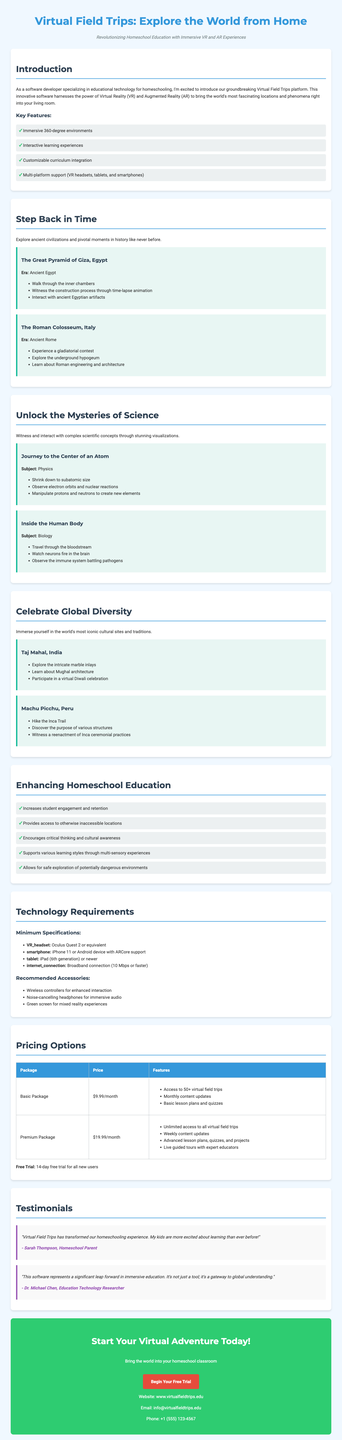what is the tagline of the brochure? The tagline is a phrase that captures the essence of the brochure, positioned prominently to attract attention.
Answer: Revolutionizing Homeschool Education with Immersive VR and AR Experiences how many historical sites are featured? The number of historical sites includes those listed under the historical sites section, specifically mentioned in the document.
Answer: 2 what is included in the Premium Package? The Premium Package consists of several features that enhance the educational experience, as detailed under pricing options.
Answer: Unlimited access to all virtual field trips, weekly content updates, advanced lesson plans, quizzes, and projects, live guided tours with expert educators which technology is required for accessing the platform? This refers to the specific requirements outlined in the technology requirements section of the document.
Answer: Oculus Quest 2 or equivalent name one of the scientific experiences available. This asks for a specific experience listed under scientific phenomena that is accessible via the software.
Answer: Journey to the Center of an Atom how does Virtual Field Trips enhance student engagement? This question seeks to understand the benefits outlined in the educational benefits section of the document, specifically regarding student engagement.
Answer: Increases student engagement and retention what is the duration of the free trial offered? This points to the information provided in the pricing section about the introductory offer for new users.
Answer: 14-day free trial who is a testimonial from? The question asks for a specific individual mentioned in the testimonials section of the document, focusing on their role.
Answer: Sarah Thompson 